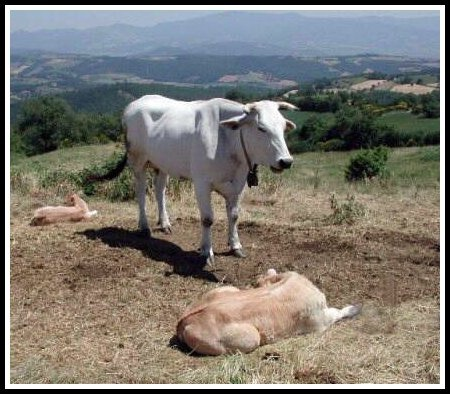Describe the objects in this image and their specific colors. I can see cow in black, gray, lightgray, and darkgray tones, cow in black and tan tones, dog in black, tan, and gray tones, and cow in black, tan, and gray tones in this image. 